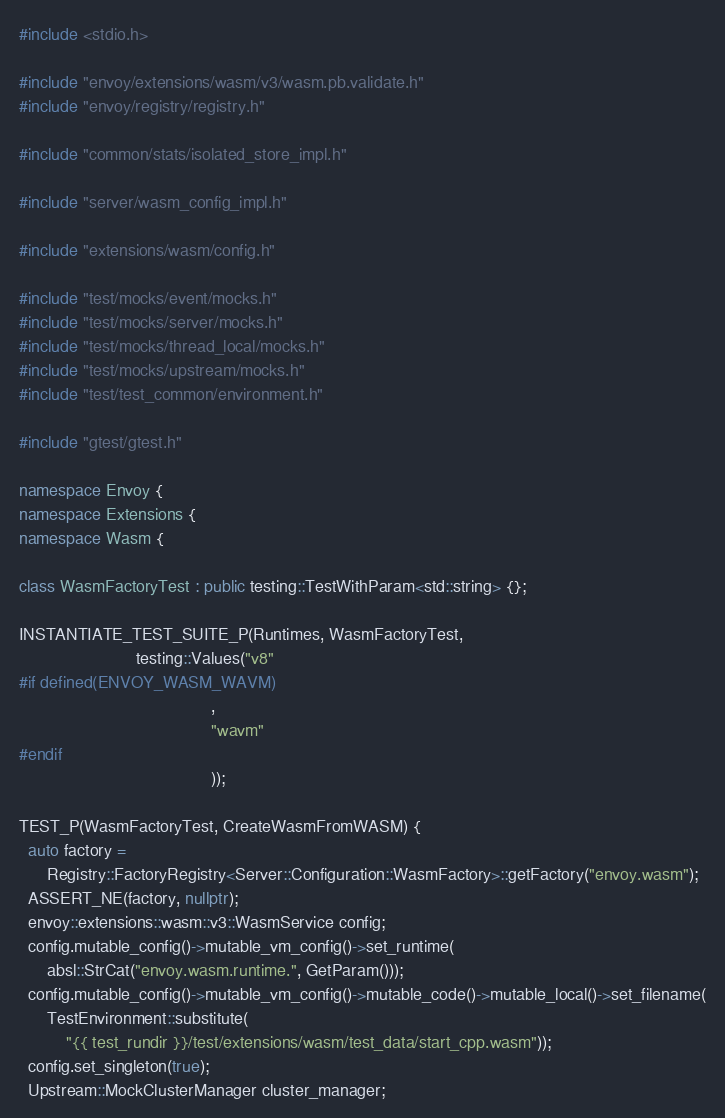<code> <loc_0><loc_0><loc_500><loc_500><_C++_>#include <stdio.h>

#include "envoy/extensions/wasm/v3/wasm.pb.validate.h"
#include "envoy/registry/registry.h"

#include "common/stats/isolated_store_impl.h"

#include "server/wasm_config_impl.h"

#include "extensions/wasm/config.h"

#include "test/mocks/event/mocks.h"
#include "test/mocks/server/mocks.h"
#include "test/mocks/thread_local/mocks.h"
#include "test/mocks/upstream/mocks.h"
#include "test/test_common/environment.h"

#include "gtest/gtest.h"

namespace Envoy {
namespace Extensions {
namespace Wasm {

class WasmFactoryTest : public testing::TestWithParam<std::string> {};

INSTANTIATE_TEST_SUITE_P(Runtimes, WasmFactoryTest,
                         testing::Values("v8"
#if defined(ENVOY_WASM_WAVM)
                                         ,
                                         "wavm"
#endif
                                         ));

TEST_P(WasmFactoryTest, CreateWasmFromWASM) {
  auto factory =
      Registry::FactoryRegistry<Server::Configuration::WasmFactory>::getFactory("envoy.wasm");
  ASSERT_NE(factory, nullptr);
  envoy::extensions::wasm::v3::WasmService config;
  config.mutable_config()->mutable_vm_config()->set_runtime(
      absl::StrCat("envoy.wasm.runtime.", GetParam()));
  config.mutable_config()->mutable_vm_config()->mutable_code()->mutable_local()->set_filename(
      TestEnvironment::substitute(
          "{{ test_rundir }}/test/extensions/wasm/test_data/start_cpp.wasm"));
  config.set_singleton(true);
  Upstream::MockClusterManager cluster_manager;</code> 